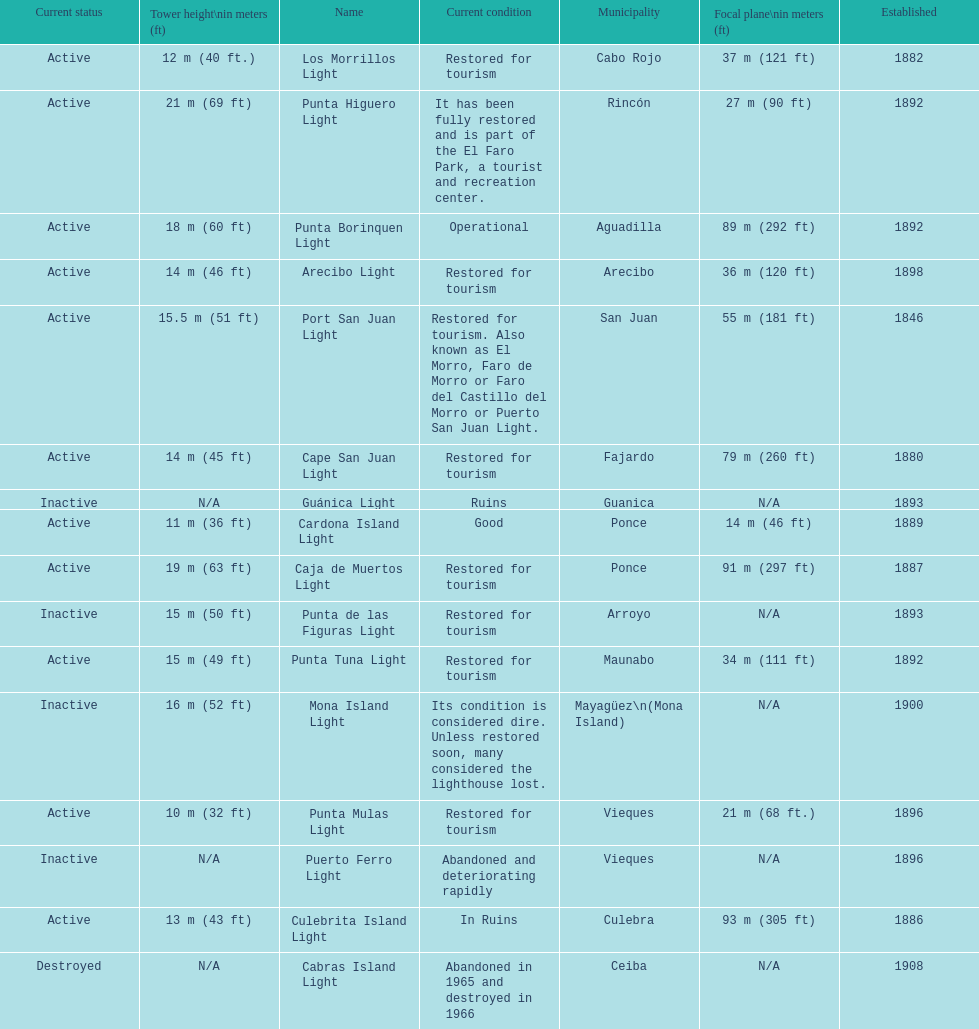What is the largest tower Punta Higuero Light. 